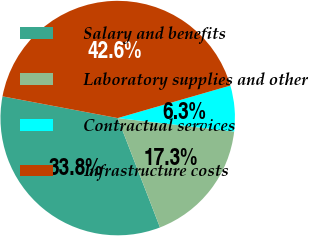<chart> <loc_0><loc_0><loc_500><loc_500><pie_chart><fcel>Salary and benefits<fcel>Laboratory supplies and other<fcel>Contractual services<fcel>Infrastructure costs<nl><fcel>33.84%<fcel>17.29%<fcel>6.31%<fcel>42.56%<nl></chart> 